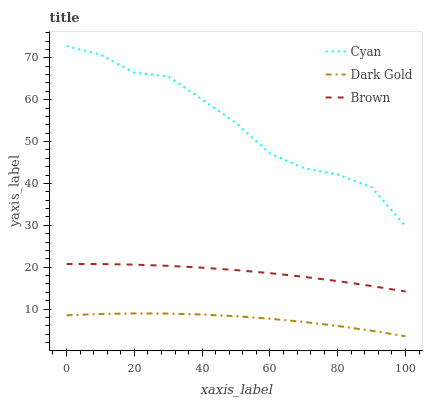Does Dark Gold have the minimum area under the curve?
Answer yes or no. Yes. Does Cyan have the maximum area under the curve?
Answer yes or no. Yes. Does Brown have the minimum area under the curve?
Answer yes or no. No. Does Brown have the maximum area under the curve?
Answer yes or no. No. Is Brown the smoothest?
Answer yes or no. Yes. Is Cyan the roughest?
Answer yes or no. Yes. Is Dark Gold the smoothest?
Answer yes or no. No. Is Dark Gold the roughest?
Answer yes or no. No. Does Dark Gold have the lowest value?
Answer yes or no. Yes. Does Brown have the lowest value?
Answer yes or no. No. Does Cyan have the highest value?
Answer yes or no. Yes. Does Brown have the highest value?
Answer yes or no. No. Is Brown less than Cyan?
Answer yes or no. Yes. Is Cyan greater than Brown?
Answer yes or no. Yes. Does Brown intersect Cyan?
Answer yes or no. No. 